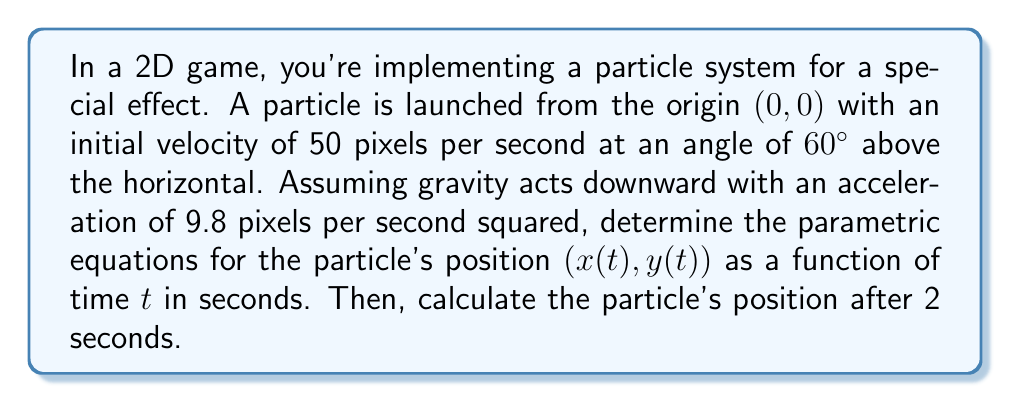Give your solution to this math problem. As a computer science student familiar with Tailwind CSS, you can think of this problem as styling the trajectory of a particle in your game. Let's break it down step-by-step:

1. Initial velocity components:
   The initial velocity can be decomposed into horizontal and vertical components:
   $$v_x = v \cos(\theta) = 50 \cos(60°) = 25 \text{ pixels/s}$$
   $$v_y = v \sin(\theta) = 50 \sin(60°) = 43.3 \text{ pixels/s}$$

2. Parametric equations:
   The horizontal motion is uniform (constant velocity), while the vertical motion is uniformly accelerated due to gravity.

   For x-coordinate:
   $$x(t) = x_0 + v_x t$$
   $$x(t) = 0 + 25t$$

   For y-coordinate:
   $$y(t) = y_0 + v_y t - \frac{1}{2}gt^2$$
   $$y(t) = 0 + 43.3t - \frac{1}{2}(9.8)t^2$$

   Therefore, the parametric equations are:
   $$x(t) = 25t$$
   $$y(t) = 43.3t - 4.9t^2$$

3. Position after 2 seconds:
   To find the position at t = 2s, we substitute t = 2 into our equations:

   $$x(2) = 25(2) = 50 \text{ pixels}$$
   $$y(2) = 43.3(2) - 4.9(2)^2 = 86.6 - 19.6 = 67 \text{ pixels}$$

[asy]
import graph;
size(200,200);
real f(real x) {return -0.0784*x^2 + 1.732*x;}
draw(graph(f,0,50));
dot((50,67));
label("(50, 67)", (50,67), E);
xaxis("x (pixels)", Arrow);
yaxis("y (pixels)", Arrow);
[/asy]

This approach is similar to how you might use utility classes in Tailwind CSS to precisely position elements on a web page, but here we're using mathematical equations to position our particle in the game world.
Answer: The parametric equations for the particle's position are:
$$x(t) = 25t$$
$$y(t) = 43.3t - 4.9t^2$$

The particle's position after 2 seconds is (50, 67) pixels. 